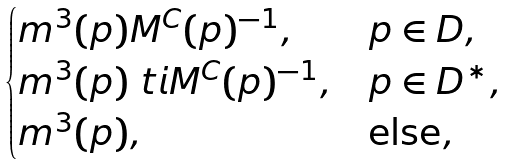Convert formula to latex. <formula><loc_0><loc_0><loc_500><loc_500>\begin{cases} m ^ { 3 } ( p ) M ^ { C } ( p ) ^ { - 1 } , & p \in D , \\ m ^ { 3 } ( p ) \ t i { M } ^ { C } ( p ) ^ { - 1 } , & p \in D ^ { * } , \\ m ^ { 3 } ( p ) , & \text {else} , \end{cases}</formula> 